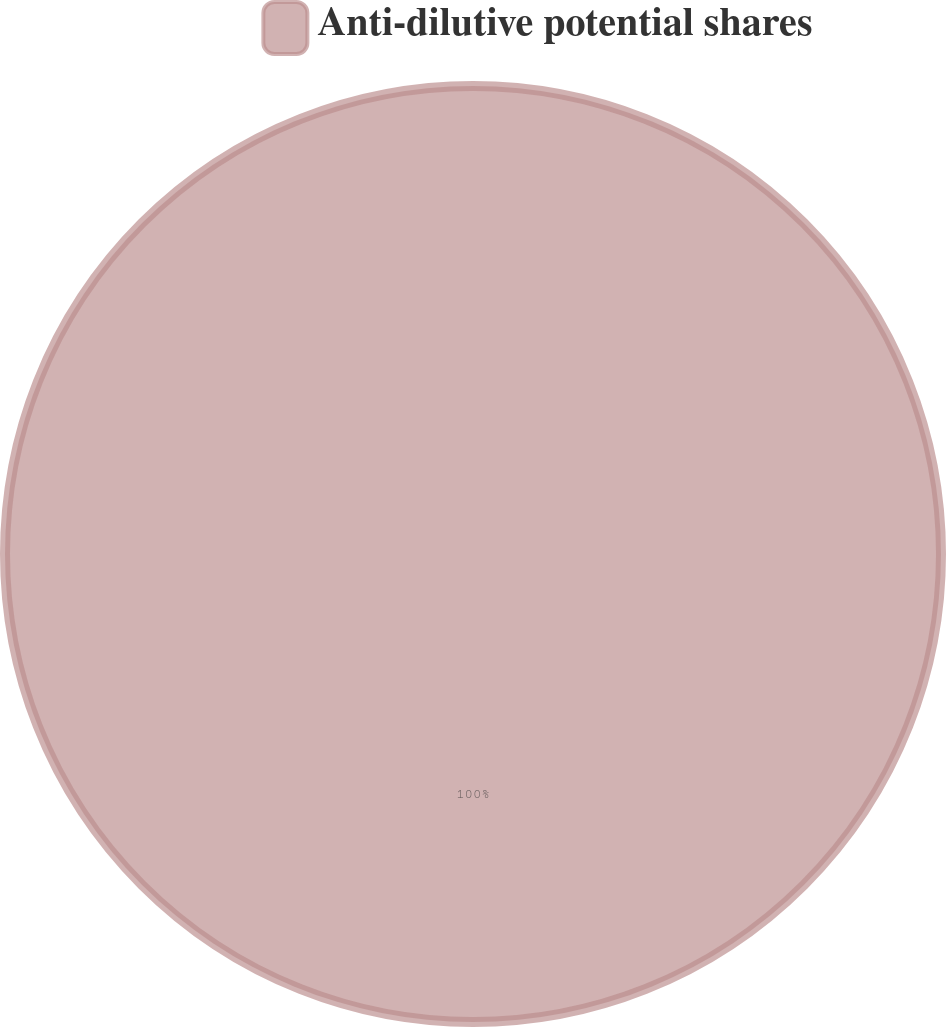<chart> <loc_0><loc_0><loc_500><loc_500><pie_chart><fcel>Anti-dilutive potential shares<nl><fcel>100.0%<nl></chart> 